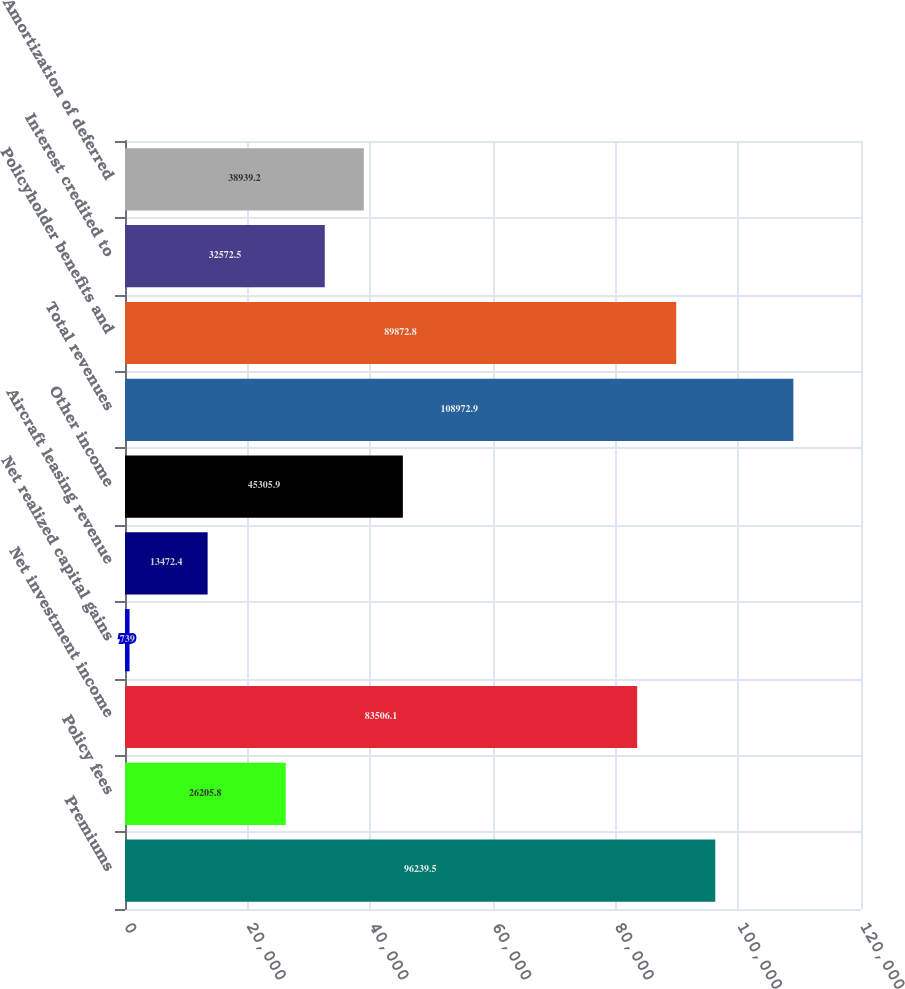<chart> <loc_0><loc_0><loc_500><loc_500><bar_chart><fcel>Premiums<fcel>Policy fees<fcel>Net investment income<fcel>Net realized capital gains<fcel>Aircraft leasing revenue<fcel>Other income<fcel>Total revenues<fcel>Policyholder benefits and<fcel>Interest credited to<fcel>Amortization of deferred<nl><fcel>96239.5<fcel>26205.8<fcel>83506.1<fcel>739<fcel>13472.4<fcel>45305.9<fcel>108973<fcel>89872.8<fcel>32572.5<fcel>38939.2<nl></chart> 